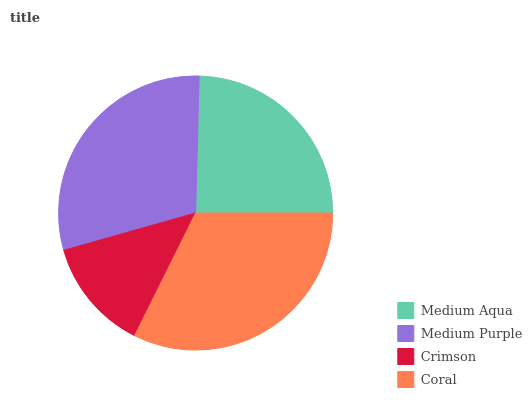Is Crimson the minimum?
Answer yes or no. Yes. Is Coral the maximum?
Answer yes or no. Yes. Is Medium Purple the minimum?
Answer yes or no. No. Is Medium Purple the maximum?
Answer yes or no. No. Is Medium Purple greater than Medium Aqua?
Answer yes or no. Yes. Is Medium Aqua less than Medium Purple?
Answer yes or no. Yes. Is Medium Aqua greater than Medium Purple?
Answer yes or no. No. Is Medium Purple less than Medium Aqua?
Answer yes or no. No. Is Medium Purple the high median?
Answer yes or no. Yes. Is Medium Aqua the low median?
Answer yes or no. Yes. Is Crimson the high median?
Answer yes or no. No. Is Medium Purple the low median?
Answer yes or no. No. 